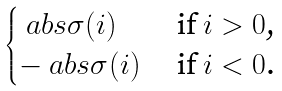Convert formula to latex. <formula><loc_0><loc_0><loc_500><loc_500>\begin{cases} \ a b s { \sigma ( i ) } & \text { if $i>0$,} \\ - \ a b s { \sigma ( i ) } & \text { if $i<0$.} \end{cases}</formula> 